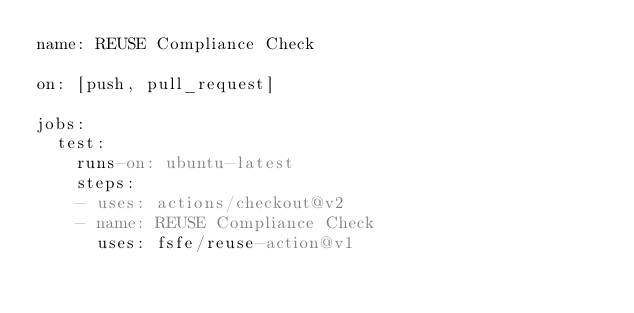Convert code to text. <code><loc_0><loc_0><loc_500><loc_500><_YAML_>name: REUSE Compliance Check

on: [push, pull_request]

jobs:
  test:
    runs-on: ubuntu-latest
    steps: 
    - uses: actions/checkout@v2
    - name: REUSE Compliance Check
      uses: fsfe/reuse-action@v1
</code> 